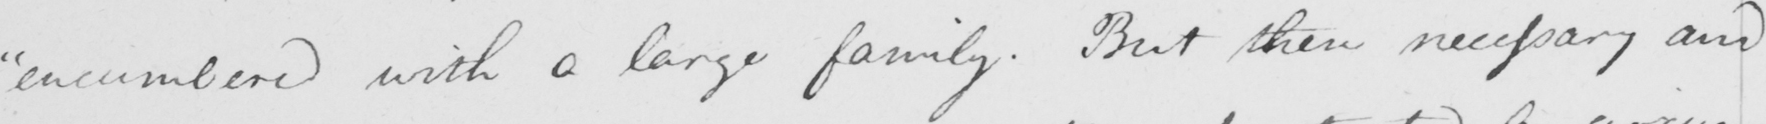Can you read and transcribe this handwriting? " encumbered with a large family . But the necessary and 